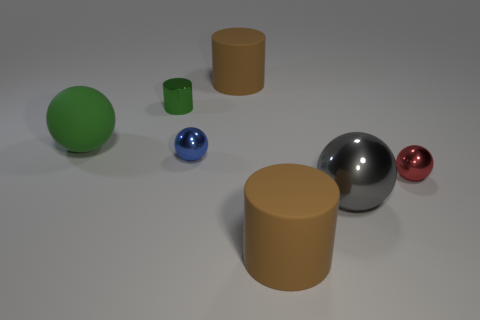Subtract all tiny green cylinders. How many cylinders are left? 2 Add 2 green rubber objects. How many objects exist? 9 Subtract all brown cylinders. How many cylinders are left? 1 Subtract 3 spheres. How many spheres are left? 1 Add 1 big yellow matte blocks. How many big yellow matte blocks exist? 1 Subtract 0 purple cylinders. How many objects are left? 7 Subtract all spheres. How many objects are left? 3 Subtract all blue cylinders. Subtract all blue cubes. How many cylinders are left? 3 Subtract all brown cylinders. How many red balls are left? 1 Subtract all matte spheres. Subtract all large rubber cylinders. How many objects are left? 4 